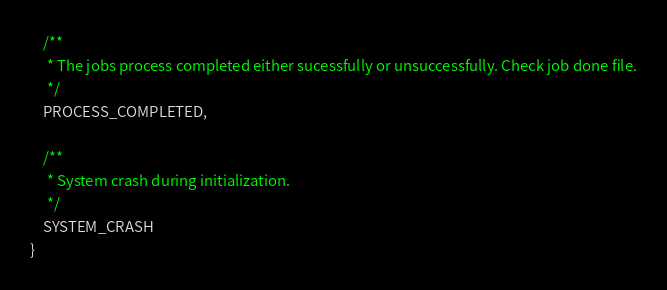Convert code to text. <code><loc_0><loc_0><loc_500><loc_500><_Java_>
    /**
     * The jobs process completed either sucessfully or unsuccessfully. Check job done file.
     */
    PROCESS_COMPLETED,

    /**
     * System crash during initialization.
     */
    SYSTEM_CRASH
}
</code> 